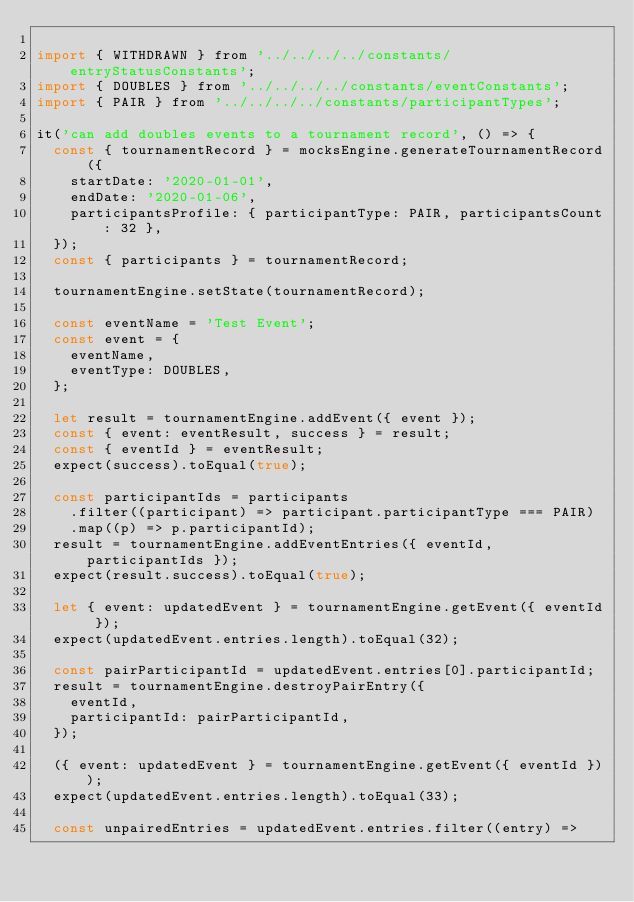<code> <loc_0><loc_0><loc_500><loc_500><_JavaScript_>
import { WITHDRAWN } from '../../../../constants/entryStatusConstants';
import { DOUBLES } from '../../../../constants/eventConstants';
import { PAIR } from '../../../../constants/participantTypes';

it('can add doubles events to a tournament record', () => {
  const { tournamentRecord } = mocksEngine.generateTournamentRecord({
    startDate: '2020-01-01',
    endDate: '2020-01-06',
    participantsProfile: { participantType: PAIR, participantsCount: 32 },
  });
  const { participants } = tournamentRecord;

  tournamentEngine.setState(tournamentRecord);

  const eventName = 'Test Event';
  const event = {
    eventName,
    eventType: DOUBLES,
  };

  let result = tournamentEngine.addEvent({ event });
  const { event: eventResult, success } = result;
  const { eventId } = eventResult;
  expect(success).toEqual(true);

  const participantIds = participants
    .filter((participant) => participant.participantType === PAIR)
    .map((p) => p.participantId);
  result = tournamentEngine.addEventEntries({ eventId, participantIds });
  expect(result.success).toEqual(true);

  let { event: updatedEvent } = tournamentEngine.getEvent({ eventId });
  expect(updatedEvent.entries.length).toEqual(32);

  const pairParticipantId = updatedEvent.entries[0].participantId;
  result = tournamentEngine.destroyPairEntry({
    eventId,
    participantId: pairParticipantId,
  });

  ({ event: updatedEvent } = tournamentEngine.getEvent({ eventId }));
  expect(updatedEvent.entries.length).toEqual(33);

  const unpairedEntries = updatedEvent.entries.filter((entry) =></code> 